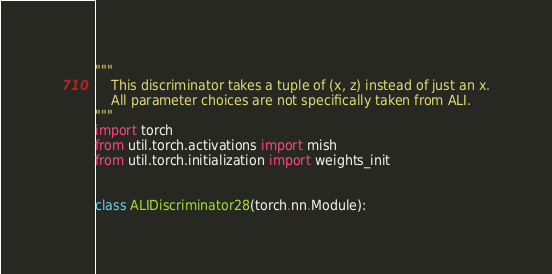<code> <loc_0><loc_0><loc_500><loc_500><_Python_>"""
    This discriminator takes a tuple of (x, z) instead of just an x.
    All parameter choices are not specifically taken from ALI.
"""
import torch
from util.torch.activations import mish
from util.torch.initialization import weights_init


class ALIDiscriminator28(torch.nn.Module):</code> 